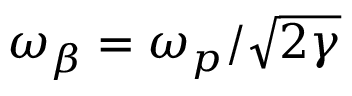Convert formula to latex. <formula><loc_0><loc_0><loc_500><loc_500>\omega _ { \beta } = \omega _ { p } / \sqrt { 2 \gamma }</formula> 